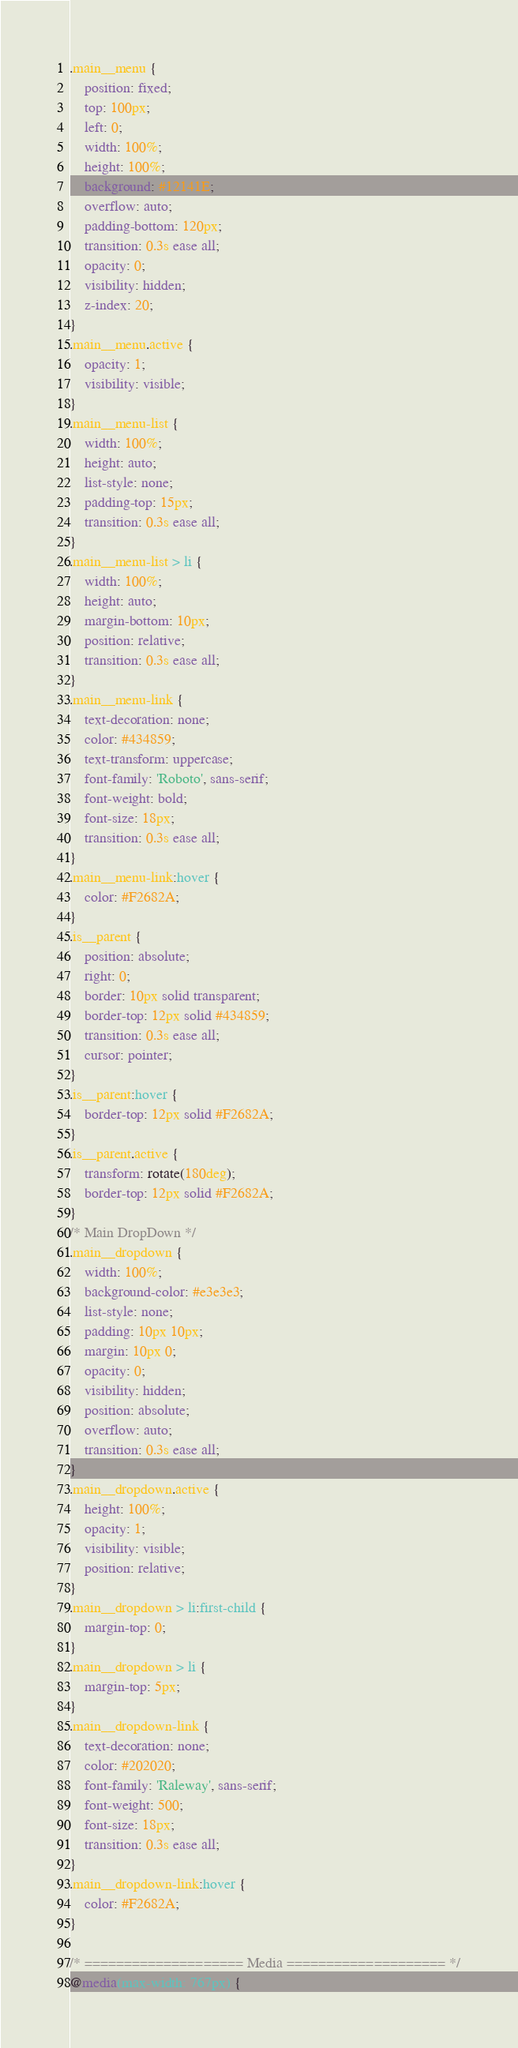<code> <loc_0><loc_0><loc_500><loc_500><_CSS_>.main__menu {
    position: fixed;
    top: 100px;
    left: 0;
    width: 100%;
    height: 100%;
    background: #12141E;
    overflow: auto;
    padding-bottom: 120px;
    transition: 0.3s ease all;
    opacity: 0;
    visibility: hidden;
    z-index: 20;
}
.main__menu.active {
    opacity: 1;
    visibility: visible;
}
.main__menu-list {
    width: 100%;
    height: auto;
    list-style: none;
    padding-top: 15px;
    transition: 0.3s ease all;
}
.main__menu-list > li {
    width: 100%;
    height: auto;
    margin-bottom: 10px;
    position: relative;
    transition: 0.3s ease all;
}
.main__menu-link {
    text-decoration: none;
    color: #434859;
    text-transform: uppercase;
    font-family: 'Roboto', sans-serif;
    font-weight: bold;
    font-size: 18px;
    transition: 0.3s ease all;
}
.main__menu-link:hover {
    color: #F2682A;
}
.is__parent {
    position: absolute;
    right: 0;
    border: 10px solid transparent;
    border-top: 12px solid #434859;
    transition: 0.3s ease all;
    cursor: pointer;
}
.is__parent:hover {
    border-top: 12px solid #F2682A;
}
.is__parent.active {
    transform: rotate(180deg);
    border-top: 12px solid #F2682A;
}
/* Main DropDown */
.main__dropdown {
    width: 100%;
    background-color: #e3e3e3;
    list-style: none;
    padding: 10px 10px;
    margin: 10px 0;
    opacity: 0;
    visibility: hidden;
    position: absolute;
    overflow: auto;
    transition: 0.3s ease all;
}
.main__dropdown.active {
    height: 100%;
    opacity: 1;
    visibility: visible;
    position: relative;
}
.main__dropdown > li:first-child {
    margin-top: 0;
}
.main__dropdown > li {
    margin-top: 5px;
}
.main__dropdown-link {
    text-decoration: none;
    color: #202020;
    font-family: 'Raleway', sans-serif;
    font-weight: 500;
    font-size: 18px;
    transition: 0.3s ease all;
}
.main__dropdown-link:hover {
    color: #F2682A;
}

/* ==================== Media ==================== */
@media(max-width: 767px) {</code> 